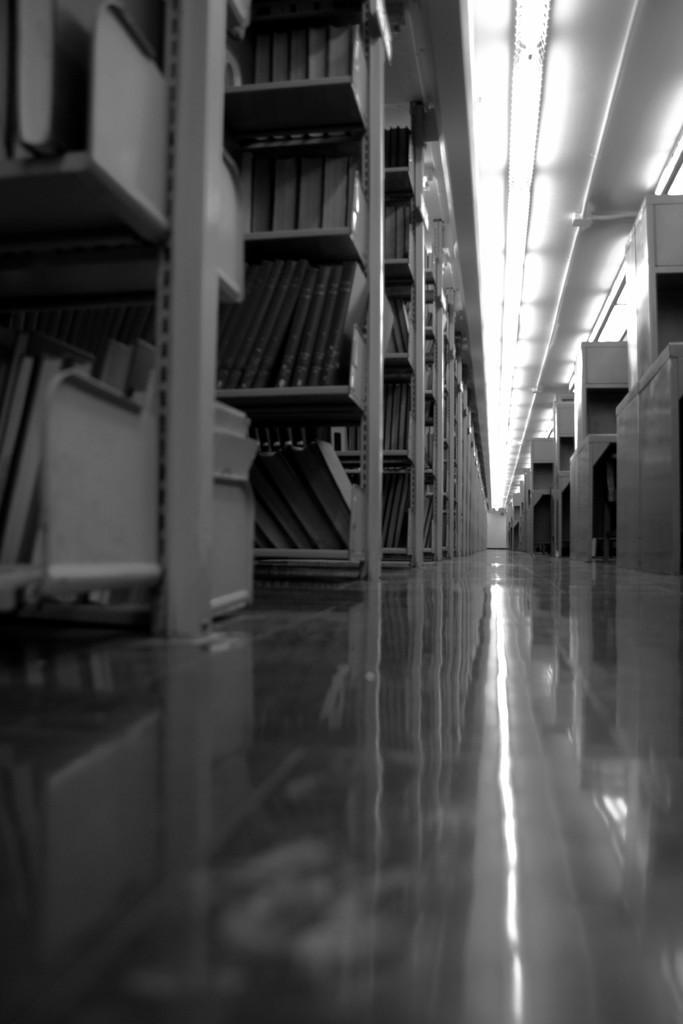Could you give a brief overview of what you see in this image? This is a black and white image. In this image we can see a group of books which are placed in the racks. We can also see a roof with some ceiling lights. 